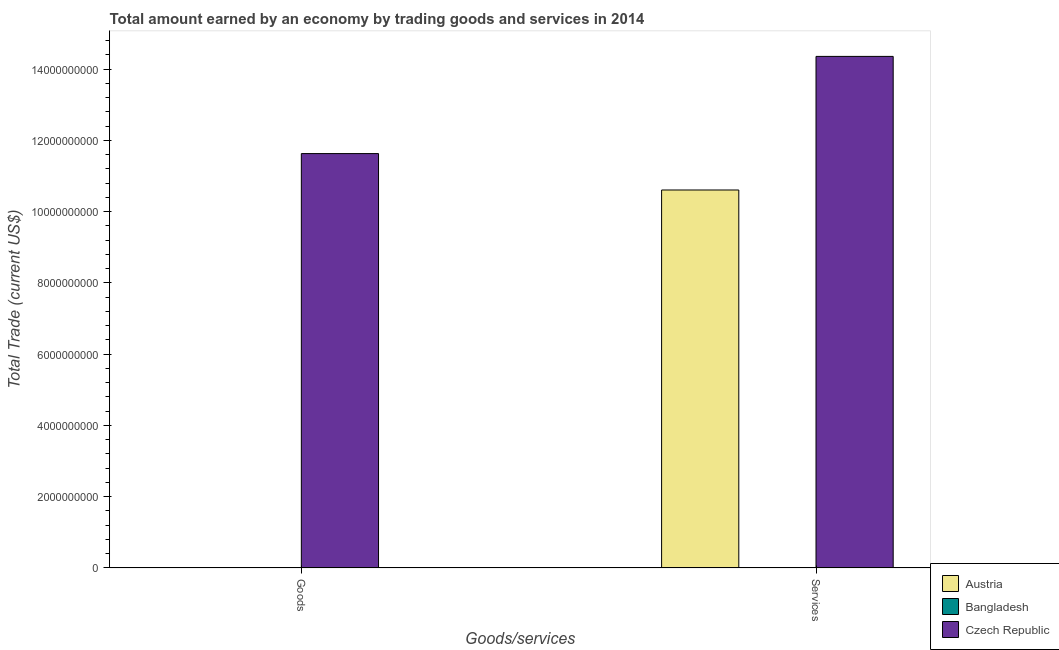How many different coloured bars are there?
Your answer should be very brief. 2. Are the number of bars on each tick of the X-axis equal?
Offer a terse response. No. What is the label of the 1st group of bars from the left?
Your answer should be compact. Goods. Across all countries, what is the maximum amount earned by trading goods?
Give a very brief answer. 1.16e+1. In which country was the amount earned by trading goods maximum?
Ensure brevity in your answer.  Czech Republic. What is the total amount earned by trading goods in the graph?
Ensure brevity in your answer.  1.16e+1. What is the average amount earned by trading services per country?
Your answer should be very brief. 8.32e+09. What is the difference between the amount earned by trading services and amount earned by trading goods in Czech Republic?
Make the answer very short. 2.73e+09. What is the ratio of the amount earned by trading services in Austria to that in Czech Republic?
Ensure brevity in your answer.  0.74. Is the amount earned by trading services in Czech Republic less than that in Austria?
Make the answer very short. No. Are all the bars in the graph horizontal?
Your response must be concise. No. Are the values on the major ticks of Y-axis written in scientific E-notation?
Offer a very short reply. No. Does the graph contain grids?
Your answer should be compact. No. Where does the legend appear in the graph?
Offer a terse response. Bottom right. How many legend labels are there?
Offer a very short reply. 3. How are the legend labels stacked?
Your answer should be compact. Vertical. What is the title of the graph?
Ensure brevity in your answer.  Total amount earned by an economy by trading goods and services in 2014. What is the label or title of the X-axis?
Provide a succinct answer. Goods/services. What is the label or title of the Y-axis?
Your answer should be compact. Total Trade (current US$). What is the Total Trade (current US$) in Austria in Goods?
Your answer should be very brief. 0. What is the Total Trade (current US$) of Czech Republic in Goods?
Offer a terse response. 1.16e+1. What is the Total Trade (current US$) in Austria in Services?
Your answer should be very brief. 1.06e+1. What is the Total Trade (current US$) of Bangladesh in Services?
Ensure brevity in your answer.  0. What is the Total Trade (current US$) in Czech Republic in Services?
Keep it short and to the point. 1.44e+1. Across all Goods/services, what is the maximum Total Trade (current US$) in Austria?
Give a very brief answer. 1.06e+1. Across all Goods/services, what is the maximum Total Trade (current US$) in Czech Republic?
Ensure brevity in your answer.  1.44e+1. Across all Goods/services, what is the minimum Total Trade (current US$) in Czech Republic?
Provide a succinct answer. 1.16e+1. What is the total Total Trade (current US$) in Austria in the graph?
Your response must be concise. 1.06e+1. What is the total Total Trade (current US$) of Czech Republic in the graph?
Make the answer very short. 2.60e+1. What is the difference between the Total Trade (current US$) of Czech Republic in Goods and that in Services?
Provide a short and direct response. -2.73e+09. What is the average Total Trade (current US$) of Austria per Goods/services?
Make the answer very short. 5.30e+09. What is the average Total Trade (current US$) of Bangladesh per Goods/services?
Your response must be concise. 0. What is the average Total Trade (current US$) of Czech Republic per Goods/services?
Ensure brevity in your answer.  1.30e+1. What is the difference between the Total Trade (current US$) in Austria and Total Trade (current US$) in Czech Republic in Services?
Your answer should be compact. -3.75e+09. What is the ratio of the Total Trade (current US$) of Czech Republic in Goods to that in Services?
Make the answer very short. 0.81. What is the difference between the highest and the second highest Total Trade (current US$) in Czech Republic?
Keep it short and to the point. 2.73e+09. What is the difference between the highest and the lowest Total Trade (current US$) in Austria?
Your answer should be compact. 1.06e+1. What is the difference between the highest and the lowest Total Trade (current US$) in Czech Republic?
Your response must be concise. 2.73e+09. 